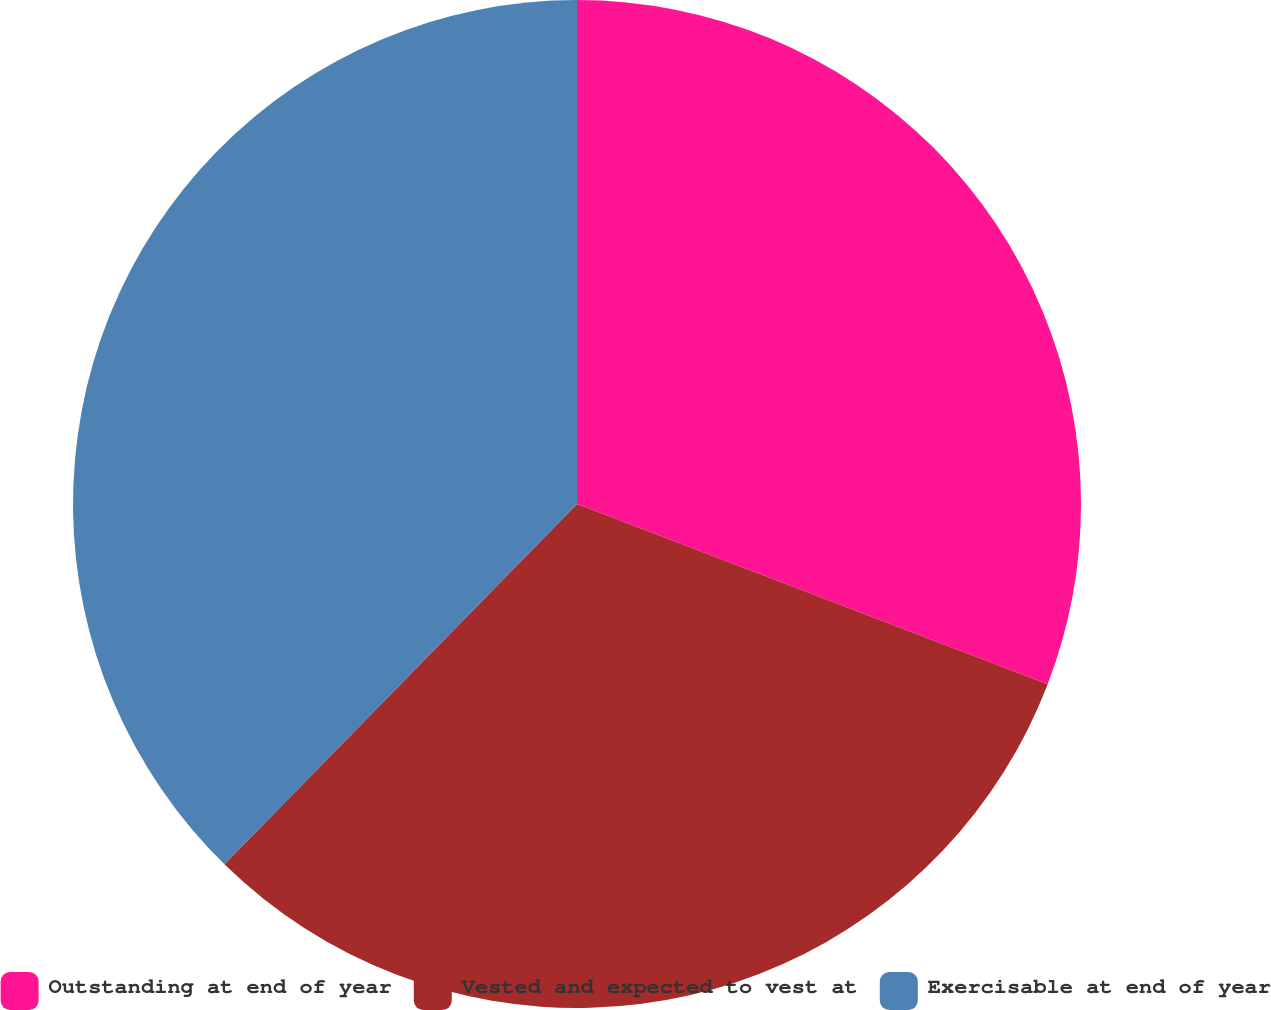Convert chart. <chart><loc_0><loc_0><loc_500><loc_500><pie_chart><fcel>Outstanding at end of year<fcel>Vested and expected to vest at<fcel>Exercisable at end of year<nl><fcel>30.82%<fcel>31.51%<fcel>37.67%<nl></chart> 